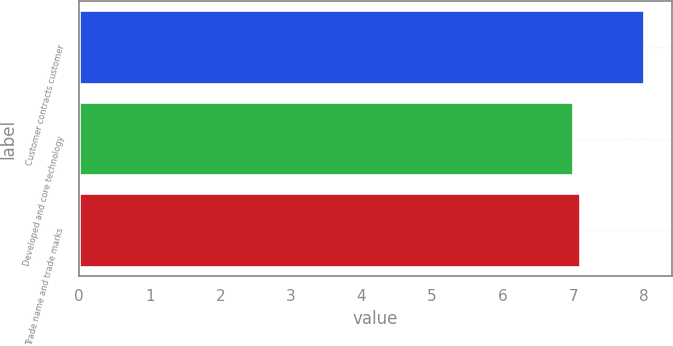Convert chart to OTSL. <chart><loc_0><loc_0><loc_500><loc_500><bar_chart><fcel>Customer contracts customer<fcel>Developed and core technology<fcel>Trade name and trade marks<nl><fcel>8<fcel>7<fcel>7.1<nl></chart> 